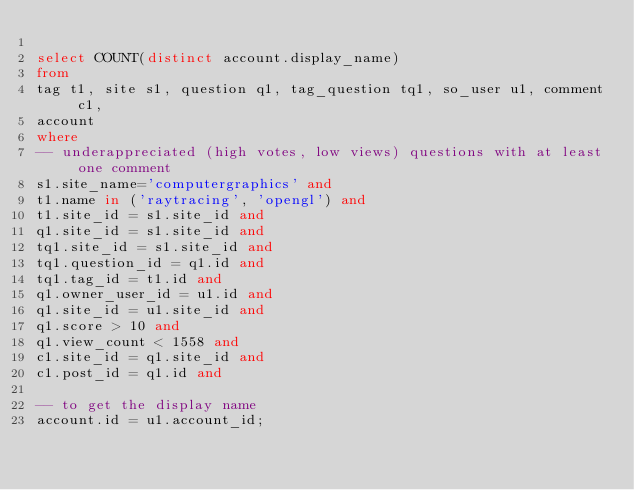Convert code to text. <code><loc_0><loc_0><loc_500><loc_500><_SQL_>
select COUNT(distinct account.display_name)
from
tag t1, site s1, question q1, tag_question tq1, so_user u1, comment c1,
account
where
-- underappreciated (high votes, low views) questions with at least one comment
s1.site_name='computergraphics' and
t1.name in ('raytracing', 'opengl') and
t1.site_id = s1.site_id and
q1.site_id = s1.site_id and
tq1.site_id = s1.site_id and
tq1.question_id = q1.id and
tq1.tag_id = t1.id and
q1.owner_user_id = u1.id and
q1.site_id = u1.site_id and
q1.score > 10 and
q1.view_count < 1558 and
c1.site_id = q1.site_id and
c1.post_id = q1.id and

-- to get the display name
account.id = u1.account_id;

</code> 